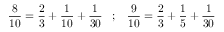<formula> <loc_0><loc_0><loc_500><loc_500>{ \frac { 8 } { 1 0 } } = { \frac { 2 } { 3 } } + { \frac { 1 } { 1 0 } } + { \frac { 1 } { 3 0 } } \, ; \, { \frac { 9 } { 1 0 } } = { \frac { 2 } { 3 } } + { \frac { 1 } { 5 } } + { \frac { 1 } { 3 0 } }</formula> 